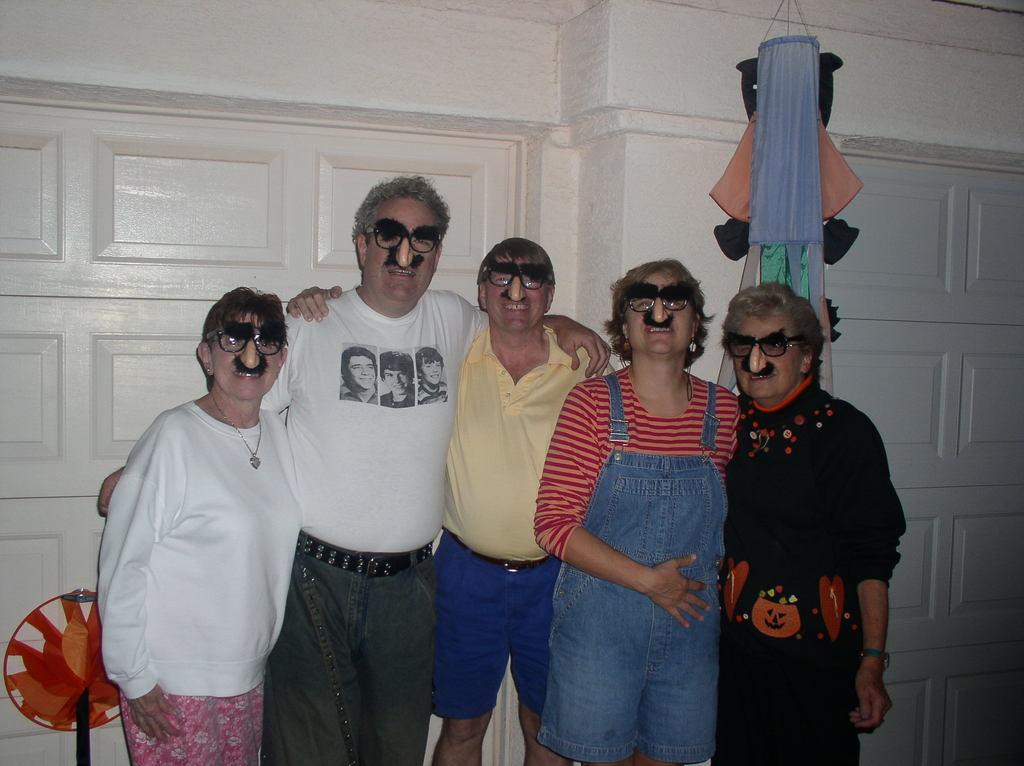How many people are in the image? There is a group of people in the image. What are the people in the image doing? The people are standing together. What are the people wearing in the image? The people are wearing clothes. What can be seen in the background of the image? There is a wall and other objects visible in the background. Is there a spy among the group of people in the image? There is no indication in the image that any of the people are spies. 